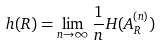Convert formula to latex. <formula><loc_0><loc_0><loc_500><loc_500>h ( R ) = \lim _ { n \to \infty } \frac { 1 } { n } H ( A _ { R } ^ { ( n ) } )</formula> 